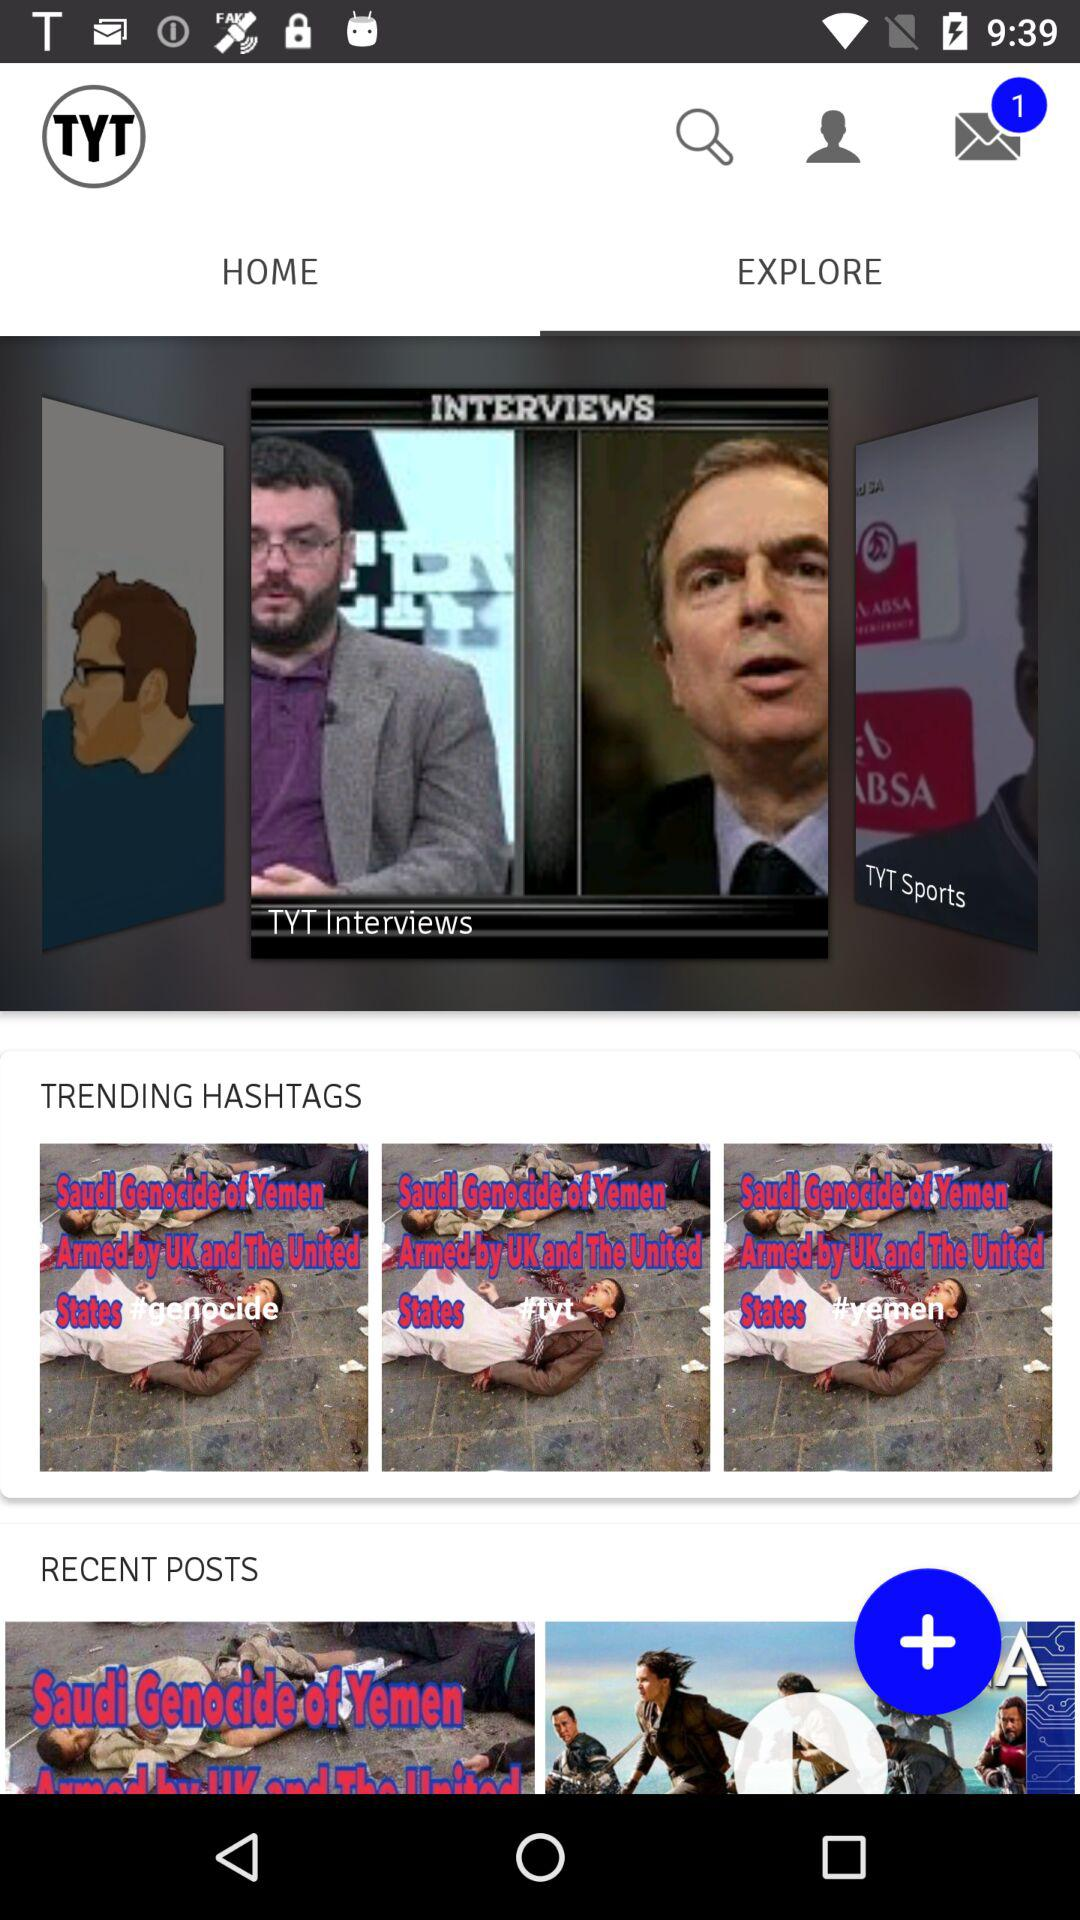What is the name of the application? The name of the application is "TYT". 